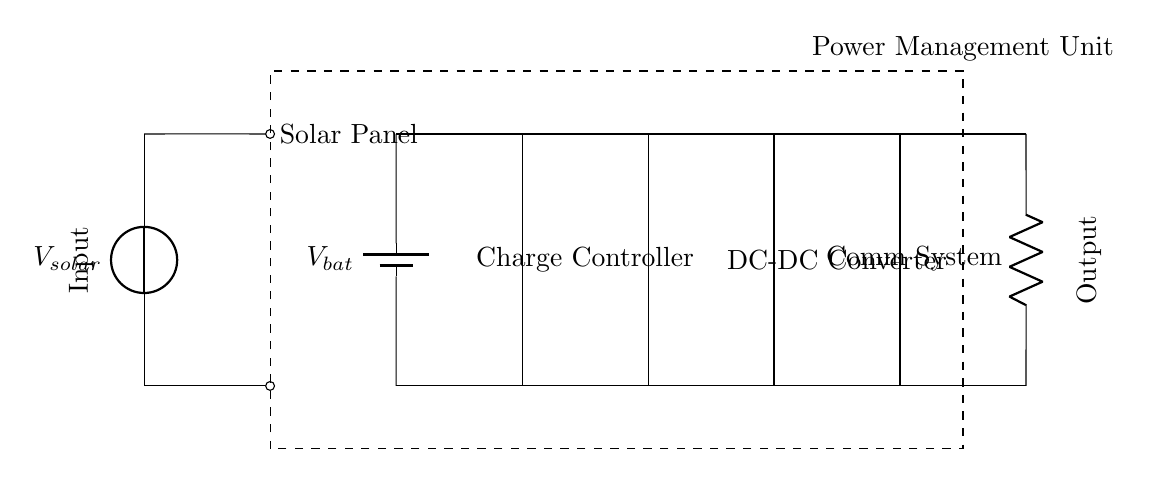What is the primary power source for this circuit? The primary power source is the solar panel, which converts sunlight into electrical energy. It is depicted at the left side of the circuit.
Answer: Solar panel How many voltage sources are present in this circuit? There are two voltage sources: one from the solar panel and one from the battery. They are both indicated in the circuit with their respective labels.
Answer: Two What component regulates the charging of the battery? The charge controller is responsible for regulating the charging of the battery, preventing overcharging and ensuring optimal battery performance. This component is clearly labeled in the circuit diagram.
Answer: Charge controller What is the purpose of the DC-DC converter in this circuit? The purpose of the DC-DC converter is to adjust the voltage levels to match the requirements of the communication system load, ensuring reliable operation. It is a crucial component connected between the charge controller and the load.
Answer: Voltage adjustment Which component is the load in this circuit? The load in this circuit is the communication system, which is drawn as a resistor. It consumes the electrical energy supplied by the battery and the DC-DC converter.
Answer: Communication system How is the power management unit defined in this circuit? The power management unit encompasses multiple components, including the solar panel, battery, charge controller, and DC-DC converter, thereby managing the overall energy distribution within the system. It is denoted by a dashed rectangle surrounding several elements.
Answer: A dashed rectangle 